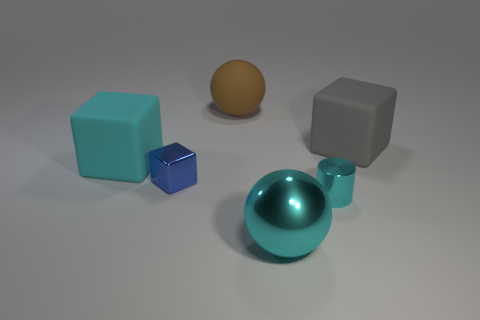Does the cyan shiny sphere have the same size as the metallic thing behind the small shiny cylinder?
Ensure brevity in your answer.  No. What size is the object that is both to the right of the brown matte object and behind the small cylinder?
Your answer should be compact. Large. Is the size of the cyan sphere the same as the blue cube?
Keep it short and to the point. No. There is a block that is the same color as the shiny cylinder; what size is it?
Provide a short and direct response. Large. What number of things are either large cyan spheres that are left of the cyan cylinder or big matte objects that are to the right of the big cyan matte thing?
Give a very brief answer. 3. What shape is the rubber object that is the same color as the large shiny sphere?
Ensure brevity in your answer.  Cube. What is the shape of the matte object that is in front of the gray matte thing?
Your answer should be compact. Cube. Do the large object in front of the cyan rubber thing and the large brown object have the same shape?
Ensure brevity in your answer.  Yes. How many things are small objects on the left side of the small shiny cylinder or cyan spheres?
Provide a succinct answer. 2. There is a small metallic thing that is the same shape as the cyan rubber thing; what is its color?
Ensure brevity in your answer.  Blue. 